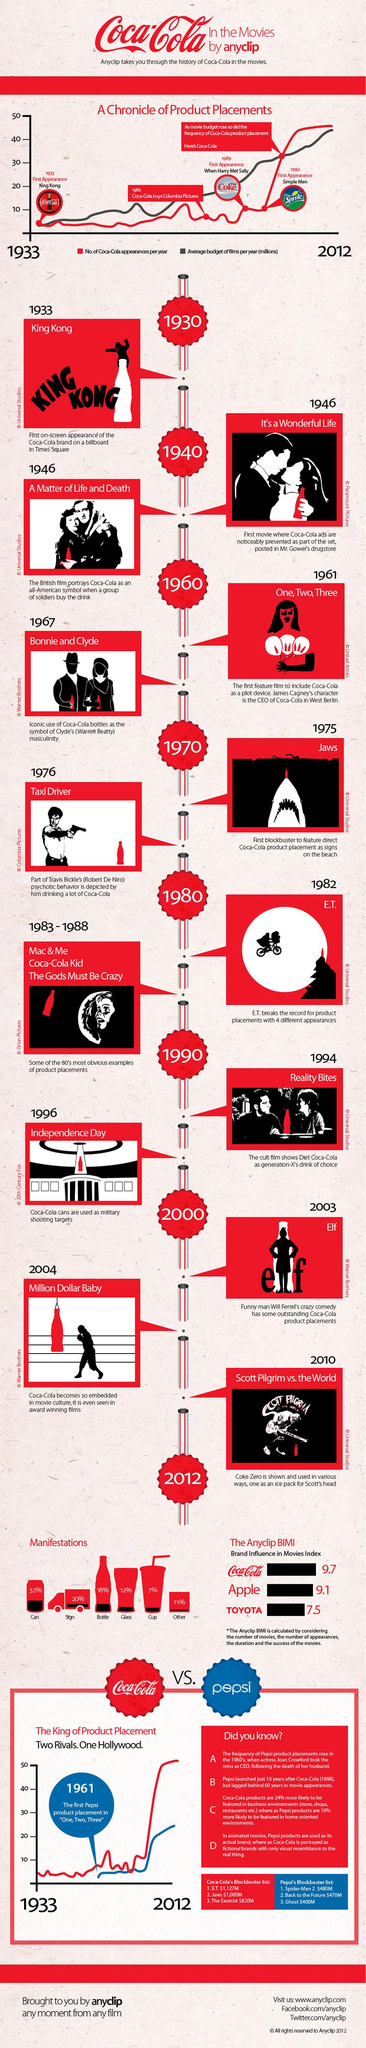Point out several critical features in this image. The Coca-Cola brand has a strong influence on movies, with a score of 9.7 in the Brand Influence in Movies Index. In the year 1933, the Coca-Cola brand had its first on-screen appearance. The movie "King Kong" gave the Coca-Cola brand its first on-screen appearance on a billboard in Times Square. In the movie Independence Day, Coca-Cola cans were used as targets for military shooting practice. The movie "Jaws," which featured direct Coca-Cola product placement as signs on the beach, is a film that is known for its use of product placement. 